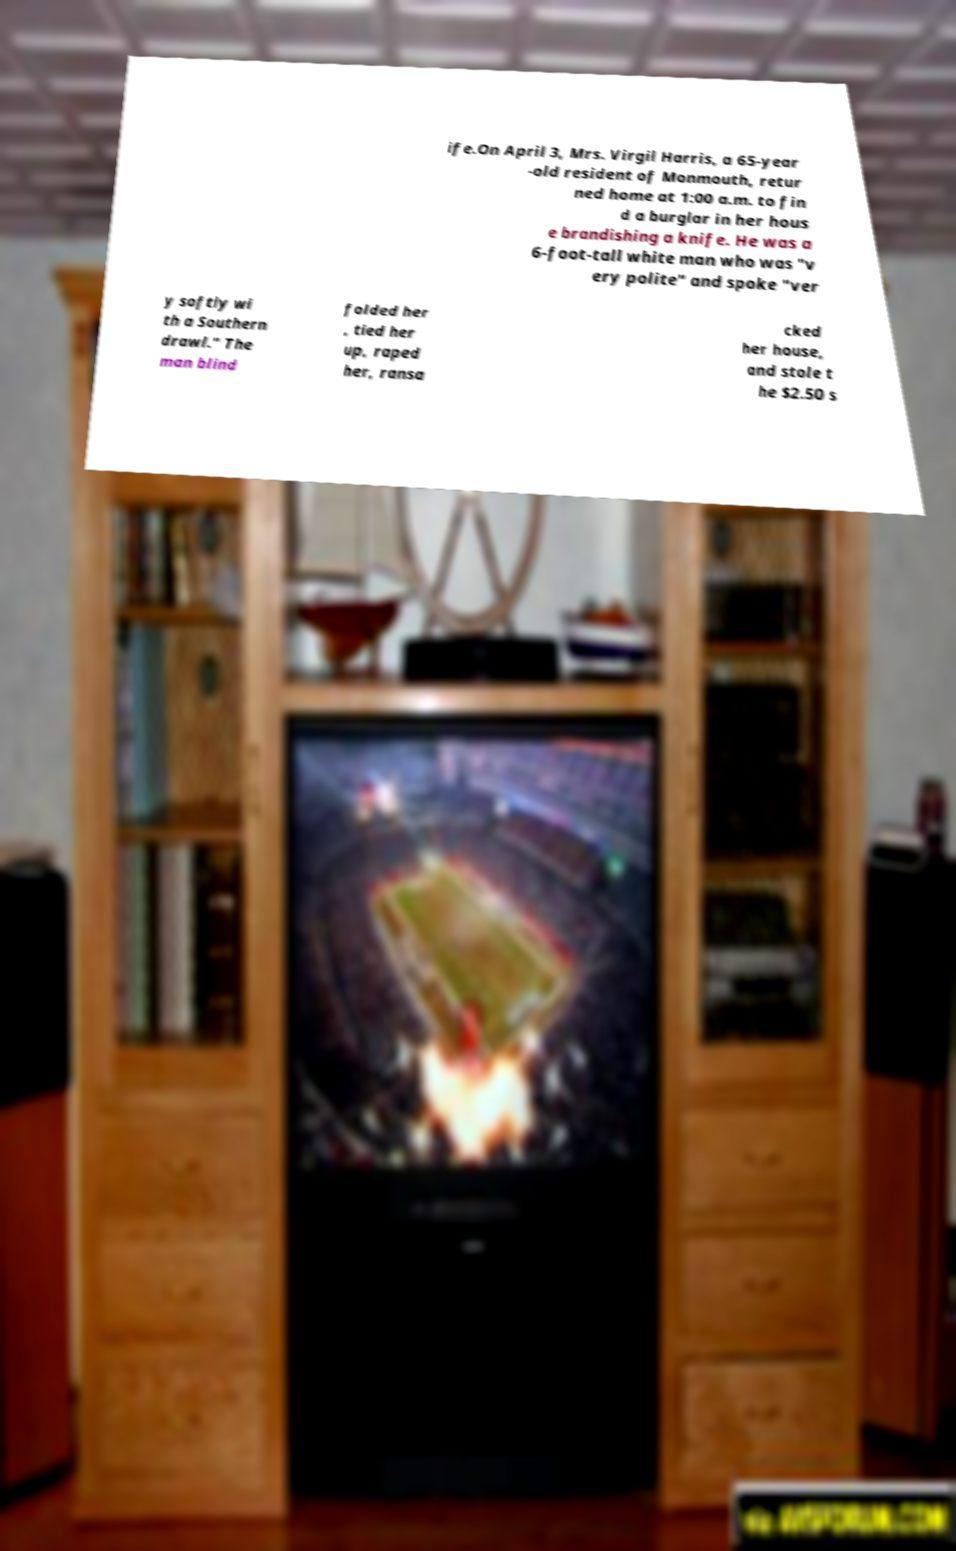Can you read and provide the text displayed in the image?This photo seems to have some interesting text. Can you extract and type it out for me? ife.On April 3, Mrs. Virgil Harris, a 65-year -old resident of Monmouth, retur ned home at 1:00 a.m. to fin d a burglar in her hous e brandishing a knife. He was a 6-foot-tall white man who was "v ery polite" and spoke "ver y softly wi th a Southern drawl." The man blind folded her , tied her up, raped her, ransa cked her house, and stole t he $2.50 s 